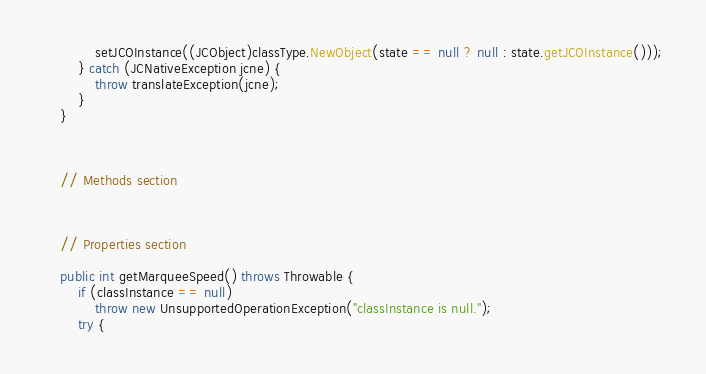<code> <loc_0><loc_0><loc_500><loc_500><_Java_>            setJCOInstance((JCObject)classType.NewObject(state == null ? null : state.getJCOInstance()));
        } catch (JCNativeException jcne) {
            throw translateException(jcne);
        }
    }


    
    // Methods section
    

    
    // Properties section
    
    public int getMarqueeSpeed() throws Throwable {
        if (classInstance == null)
            throw new UnsupportedOperationException("classInstance is null.");
        try {</code> 